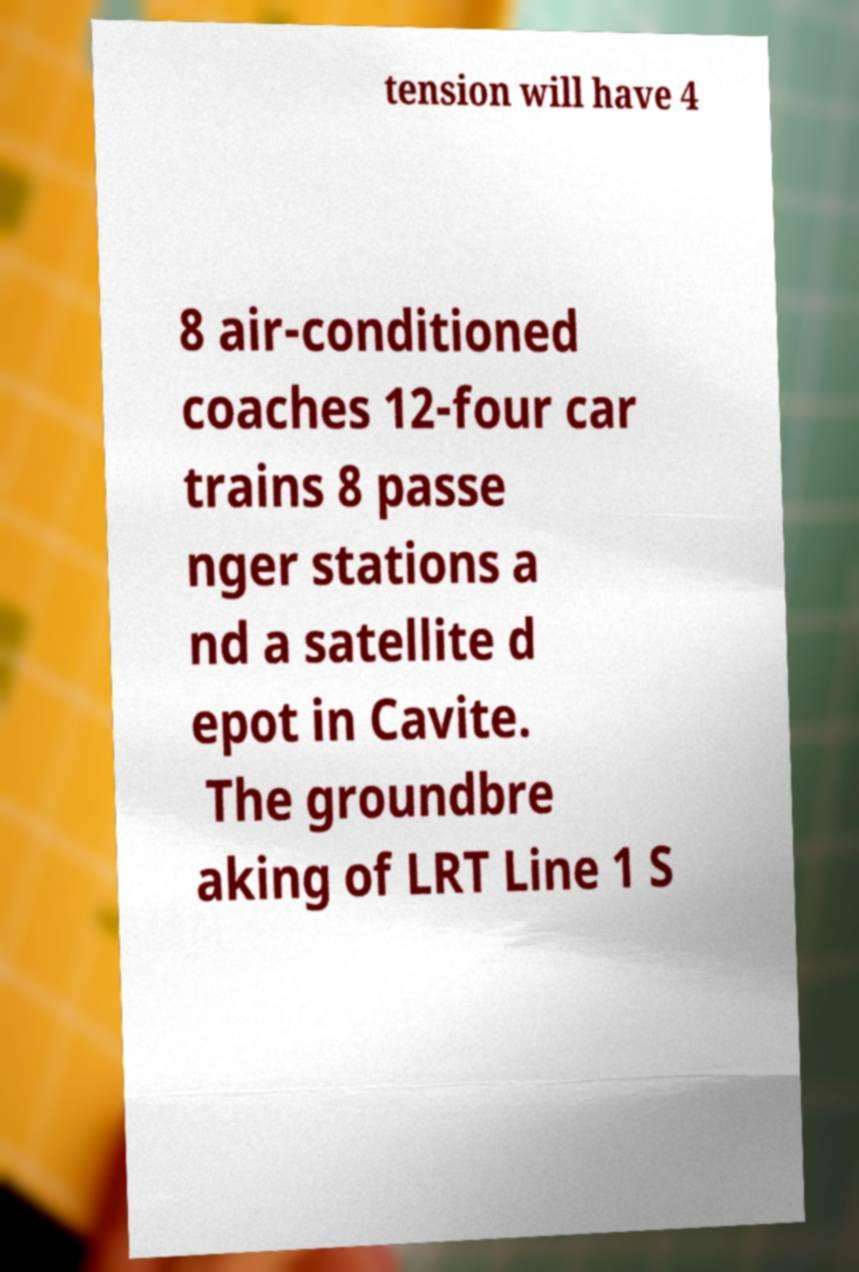Please read and relay the text visible in this image. What does it say? tension will have 4 8 air-conditioned coaches 12-four car trains 8 passe nger stations a nd a satellite d epot in Cavite. The groundbre aking of LRT Line 1 S 